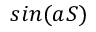Convert formula to latex. <formula><loc_0><loc_0><loc_500><loc_500>\sin ( a S )</formula> 